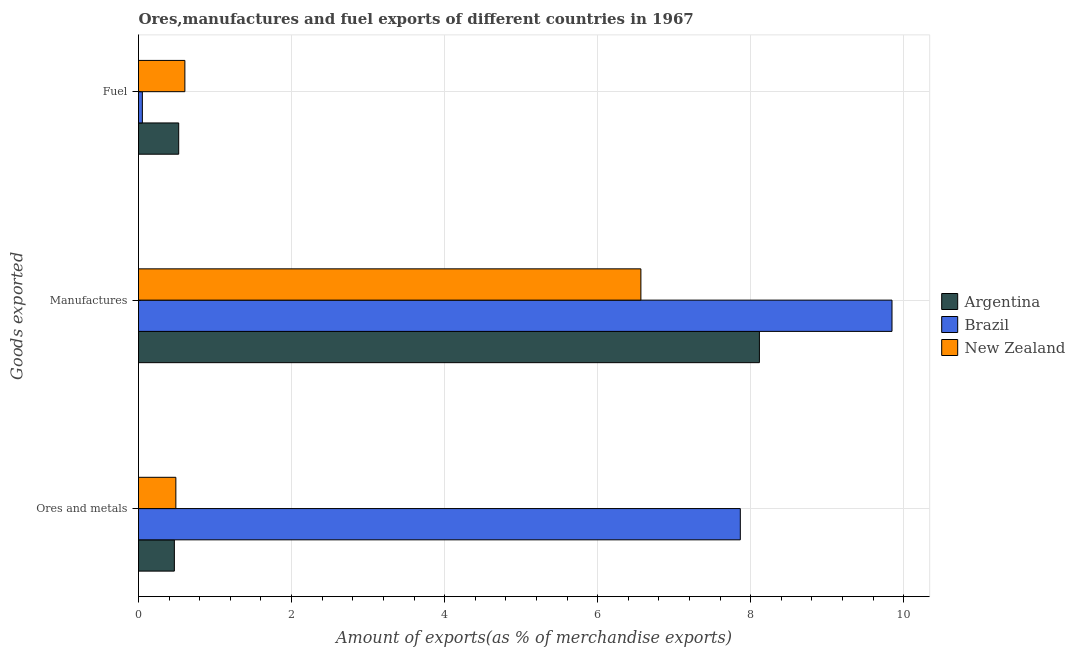How many groups of bars are there?
Provide a short and direct response. 3. How many bars are there on the 1st tick from the top?
Your response must be concise. 3. What is the label of the 1st group of bars from the top?
Keep it short and to the point. Fuel. What is the percentage of fuel exports in Brazil?
Provide a succinct answer. 0.05. Across all countries, what is the maximum percentage of ores and metals exports?
Ensure brevity in your answer.  7.86. Across all countries, what is the minimum percentage of manufactures exports?
Offer a very short reply. 6.56. In which country was the percentage of fuel exports maximum?
Provide a succinct answer. New Zealand. In which country was the percentage of fuel exports minimum?
Your answer should be very brief. Brazil. What is the total percentage of fuel exports in the graph?
Your answer should be compact. 1.18. What is the difference between the percentage of fuel exports in Brazil and that in New Zealand?
Give a very brief answer. -0.56. What is the difference between the percentage of fuel exports in Brazil and the percentage of manufactures exports in New Zealand?
Provide a succinct answer. -6.51. What is the average percentage of ores and metals exports per country?
Give a very brief answer. 2.94. What is the difference between the percentage of fuel exports and percentage of ores and metals exports in Argentina?
Offer a terse response. 0.06. In how many countries, is the percentage of ores and metals exports greater than 9.6 %?
Ensure brevity in your answer.  0. What is the ratio of the percentage of fuel exports in Brazil to that in Argentina?
Offer a very short reply. 0.1. Is the percentage of ores and metals exports in Brazil less than that in New Zealand?
Give a very brief answer. No. What is the difference between the highest and the second highest percentage of manufactures exports?
Offer a very short reply. 1.73. What is the difference between the highest and the lowest percentage of manufactures exports?
Your answer should be very brief. 3.28. In how many countries, is the percentage of manufactures exports greater than the average percentage of manufactures exports taken over all countries?
Offer a very short reply. 1. What does the 1st bar from the top in Manufactures represents?
Offer a very short reply. New Zealand. What does the 2nd bar from the bottom in Ores and metals represents?
Your response must be concise. Brazil. Are all the bars in the graph horizontal?
Ensure brevity in your answer.  Yes. How many countries are there in the graph?
Keep it short and to the point. 3. Are the values on the major ticks of X-axis written in scientific E-notation?
Offer a terse response. No. Where does the legend appear in the graph?
Keep it short and to the point. Center right. How many legend labels are there?
Your answer should be compact. 3. What is the title of the graph?
Your response must be concise. Ores,manufactures and fuel exports of different countries in 1967. What is the label or title of the X-axis?
Give a very brief answer. Amount of exports(as % of merchandise exports). What is the label or title of the Y-axis?
Your answer should be compact. Goods exported. What is the Amount of exports(as % of merchandise exports) of Argentina in Ores and metals?
Your answer should be very brief. 0.47. What is the Amount of exports(as % of merchandise exports) in Brazil in Ores and metals?
Provide a succinct answer. 7.86. What is the Amount of exports(as % of merchandise exports) of New Zealand in Ores and metals?
Make the answer very short. 0.49. What is the Amount of exports(as % of merchandise exports) of Argentina in Manufactures?
Keep it short and to the point. 8.11. What is the Amount of exports(as % of merchandise exports) in Brazil in Manufactures?
Your answer should be compact. 9.85. What is the Amount of exports(as % of merchandise exports) of New Zealand in Manufactures?
Keep it short and to the point. 6.56. What is the Amount of exports(as % of merchandise exports) of Argentina in Fuel?
Offer a terse response. 0.53. What is the Amount of exports(as % of merchandise exports) in Brazil in Fuel?
Provide a short and direct response. 0.05. What is the Amount of exports(as % of merchandise exports) in New Zealand in Fuel?
Your response must be concise. 0.61. Across all Goods exported, what is the maximum Amount of exports(as % of merchandise exports) in Argentina?
Offer a very short reply. 8.11. Across all Goods exported, what is the maximum Amount of exports(as % of merchandise exports) of Brazil?
Your response must be concise. 9.85. Across all Goods exported, what is the maximum Amount of exports(as % of merchandise exports) in New Zealand?
Offer a very short reply. 6.56. Across all Goods exported, what is the minimum Amount of exports(as % of merchandise exports) in Argentina?
Keep it short and to the point. 0.47. Across all Goods exported, what is the minimum Amount of exports(as % of merchandise exports) in Brazil?
Offer a very short reply. 0.05. Across all Goods exported, what is the minimum Amount of exports(as % of merchandise exports) of New Zealand?
Your response must be concise. 0.49. What is the total Amount of exports(as % of merchandise exports) in Argentina in the graph?
Offer a very short reply. 9.11. What is the total Amount of exports(as % of merchandise exports) of Brazil in the graph?
Your answer should be compact. 17.76. What is the total Amount of exports(as % of merchandise exports) in New Zealand in the graph?
Offer a terse response. 7.66. What is the difference between the Amount of exports(as % of merchandise exports) of Argentina in Ores and metals and that in Manufactures?
Your response must be concise. -7.64. What is the difference between the Amount of exports(as % of merchandise exports) of Brazil in Ores and metals and that in Manufactures?
Offer a terse response. -1.98. What is the difference between the Amount of exports(as % of merchandise exports) of New Zealand in Ores and metals and that in Manufactures?
Provide a succinct answer. -6.08. What is the difference between the Amount of exports(as % of merchandise exports) of Argentina in Ores and metals and that in Fuel?
Ensure brevity in your answer.  -0.06. What is the difference between the Amount of exports(as % of merchandise exports) of Brazil in Ores and metals and that in Fuel?
Provide a succinct answer. 7.81. What is the difference between the Amount of exports(as % of merchandise exports) in New Zealand in Ores and metals and that in Fuel?
Give a very brief answer. -0.12. What is the difference between the Amount of exports(as % of merchandise exports) in Argentina in Manufactures and that in Fuel?
Offer a terse response. 7.59. What is the difference between the Amount of exports(as % of merchandise exports) of Brazil in Manufactures and that in Fuel?
Your answer should be compact. 9.8. What is the difference between the Amount of exports(as % of merchandise exports) in New Zealand in Manufactures and that in Fuel?
Give a very brief answer. 5.96. What is the difference between the Amount of exports(as % of merchandise exports) in Argentina in Ores and metals and the Amount of exports(as % of merchandise exports) in Brazil in Manufactures?
Your response must be concise. -9.38. What is the difference between the Amount of exports(as % of merchandise exports) in Argentina in Ores and metals and the Amount of exports(as % of merchandise exports) in New Zealand in Manufactures?
Your answer should be compact. -6.1. What is the difference between the Amount of exports(as % of merchandise exports) of Brazil in Ores and metals and the Amount of exports(as % of merchandise exports) of New Zealand in Manufactures?
Give a very brief answer. 1.3. What is the difference between the Amount of exports(as % of merchandise exports) of Argentina in Ores and metals and the Amount of exports(as % of merchandise exports) of Brazil in Fuel?
Provide a short and direct response. 0.42. What is the difference between the Amount of exports(as % of merchandise exports) of Argentina in Ores and metals and the Amount of exports(as % of merchandise exports) of New Zealand in Fuel?
Your answer should be very brief. -0.14. What is the difference between the Amount of exports(as % of merchandise exports) of Brazil in Ores and metals and the Amount of exports(as % of merchandise exports) of New Zealand in Fuel?
Ensure brevity in your answer.  7.26. What is the difference between the Amount of exports(as % of merchandise exports) of Argentina in Manufactures and the Amount of exports(as % of merchandise exports) of Brazil in Fuel?
Give a very brief answer. 8.06. What is the difference between the Amount of exports(as % of merchandise exports) in Argentina in Manufactures and the Amount of exports(as % of merchandise exports) in New Zealand in Fuel?
Your answer should be compact. 7.51. What is the difference between the Amount of exports(as % of merchandise exports) of Brazil in Manufactures and the Amount of exports(as % of merchandise exports) of New Zealand in Fuel?
Your answer should be very brief. 9.24. What is the average Amount of exports(as % of merchandise exports) of Argentina per Goods exported?
Provide a short and direct response. 3.04. What is the average Amount of exports(as % of merchandise exports) of Brazil per Goods exported?
Your response must be concise. 5.92. What is the average Amount of exports(as % of merchandise exports) in New Zealand per Goods exported?
Give a very brief answer. 2.55. What is the difference between the Amount of exports(as % of merchandise exports) of Argentina and Amount of exports(as % of merchandise exports) of Brazil in Ores and metals?
Your response must be concise. -7.39. What is the difference between the Amount of exports(as % of merchandise exports) of Argentina and Amount of exports(as % of merchandise exports) of New Zealand in Ores and metals?
Provide a succinct answer. -0.02. What is the difference between the Amount of exports(as % of merchandise exports) in Brazil and Amount of exports(as % of merchandise exports) in New Zealand in Ores and metals?
Offer a very short reply. 7.38. What is the difference between the Amount of exports(as % of merchandise exports) in Argentina and Amount of exports(as % of merchandise exports) in Brazil in Manufactures?
Make the answer very short. -1.73. What is the difference between the Amount of exports(as % of merchandise exports) in Argentina and Amount of exports(as % of merchandise exports) in New Zealand in Manufactures?
Your response must be concise. 1.55. What is the difference between the Amount of exports(as % of merchandise exports) in Brazil and Amount of exports(as % of merchandise exports) in New Zealand in Manufactures?
Your response must be concise. 3.28. What is the difference between the Amount of exports(as % of merchandise exports) of Argentina and Amount of exports(as % of merchandise exports) of Brazil in Fuel?
Your answer should be compact. 0.47. What is the difference between the Amount of exports(as % of merchandise exports) of Argentina and Amount of exports(as % of merchandise exports) of New Zealand in Fuel?
Your answer should be very brief. -0.08. What is the difference between the Amount of exports(as % of merchandise exports) in Brazil and Amount of exports(as % of merchandise exports) in New Zealand in Fuel?
Ensure brevity in your answer.  -0.56. What is the ratio of the Amount of exports(as % of merchandise exports) of Argentina in Ores and metals to that in Manufactures?
Your answer should be compact. 0.06. What is the ratio of the Amount of exports(as % of merchandise exports) in Brazil in Ores and metals to that in Manufactures?
Offer a very short reply. 0.8. What is the ratio of the Amount of exports(as % of merchandise exports) of New Zealand in Ores and metals to that in Manufactures?
Your response must be concise. 0.07. What is the ratio of the Amount of exports(as % of merchandise exports) in Argentina in Ores and metals to that in Fuel?
Ensure brevity in your answer.  0.89. What is the ratio of the Amount of exports(as % of merchandise exports) in Brazil in Ores and metals to that in Fuel?
Make the answer very short. 155.99. What is the ratio of the Amount of exports(as % of merchandise exports) in New Zealand in Ores and metals to that in Fuel?
Keep it short and to the point. 0.81. What is the ratio of the Amount of exports(as % of merchandise exports) in Argentina in Manufactures to that in Fuel?
Provide a short and direct response. 15.45. What is the ratio of the Amount of exports(as % of merchandise exports) of Brazil in Manufactures to that in Fuel?
Make the answer very short. 195.31. What is the ratio of the Amount of exports(as % of merchandise exports) of New Zealand in Manufactures to that in Fuel?
Keep it short and to the point. 10.84. What is the difference between the highest and the second highest Amount of exports(as % of merchandise exports) of Argentina?
Offer a very short reply. 7.59. What is the difference between the highest and the second highest Amount of exports(as % of merchandise exports) in Brazil?
Give a very brief answer. 1.98. What is the difference between the highest and the second highest Amount of exports(as % of merchandise exports) in New Zealand?
Provide a succinct answer. 5.96. What is the difference between the highest and the lowest Amount of exports(as % of merchandise exports) of Argentina?
Offer a very short reply. 7.64. What is the difference between the highest and the lowest Amount of exports(as % of merchandise exports) of Brazil?
Ensure brevity in your answer.  9.8. What is the difference between the highest and the lowest Amount of exports(as % of merchandise exports) of New Zealand?
Offer a terse response. 6.08. 